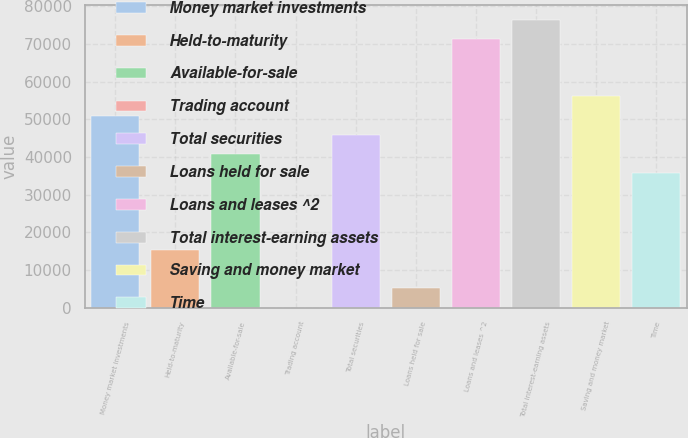Convert chart. <chart><loc_0><loc_0><loc_500><loc_500><bar_chart><fcel>Money market investments<fcel>Held-to-maturity<fcel>Available-for-sale<fcel>Trading account<fcel>Total securities<fcel>Loans held for sale<fcel>Loans and leases ^2<fcel>Total interest-earning assets<fcel>Saving and money market<fcel>Time<nl><fcel>51005<fcel>15323.9<fcel>40810.4<fcel>32<fcel>45907.7<fcel>5129.3<fcel>71394.2<fcel>76491.5<fcel>56102.3<fcel>35713.1<nl></chart> 